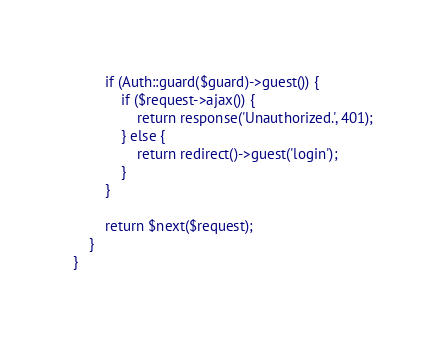<code> <loc_0><loc_0><loc_500><loc_500><_PHP_>        if (Auth::guard($guard)->guest()) {
            if ($request->ajax()) {
                return response('Unauthorized.', 401);
            } else {
                return redirect()->guest('login');
            }
        }

        return $next($request);
    }
}
</code> 